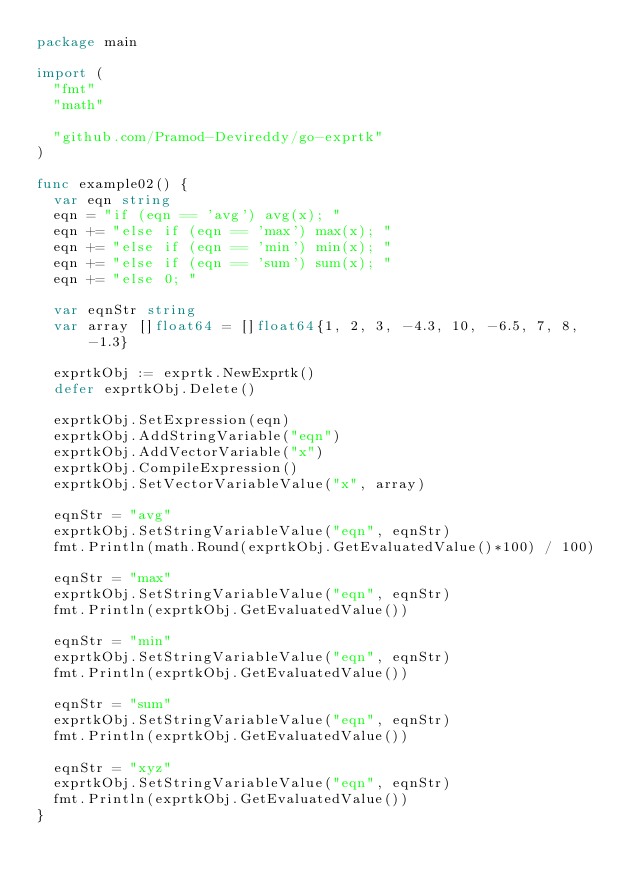<code> <loc_0><loc_0><loc_500><loc_500><_Go_>package main

import (
	"fmt"
	"math"

	"github.com/Pramod-Devireddy/go-exprtk"
)

func example02() {
	var eqn string
	eqn = "if (eqn == 'avg') avg(x); "
	eqn += "else if (eqn == 'max') max(x); "
	eqn += "else if (eqn == 'min') min(x); "
	eqn += "else if (eqn == 'sum') sum(x); "
	eqn += "else 0; "

	var eqnStr string
	var array []float64 = []float64{1, 2, 3, -4.3, 10, -6.5, 7, 8, -1.3}

	exprtkObj := exprtk.NewExprtk()
	defer exprtkObj.Delete()

	exprtkObj.SetExpression(eqn)
	exprtkObj.AddStringVariable("eqn")
	exprtkObj.AddVectorVariable("x")
	exprtkObj.CompileExpression()
	exprtkObj.SetVectorVariableValue("x", array)

	eqnStr = "avg"
	exprtkObj.SetStringVariableValue("eqn", eqnStr)
	fmt.Println(math.Round(exprtkObj.GetEvaluatedValue()*100) / 100)

	eqnStr = "max"
	exprtkObj.SetStringVariableValue("eqn", eqnStr)
	fmt.Println(exprtkObj.GetEvaluatedValue())

	eqnStr = "min"
	exprtkObj.SetStringVariableValue("eqn", eqnStr)
	fmt.Println(exprtkObj.GetEvaluatedValue())

	eqnStr = "sum"
	exprtkObj.SetStringVariableValue("eqn", eqnStr)
	fmt.Println(exprtkObj.GetEvaluatedValue())

	eqnStr = "xyz"
	exprtkObj.SetStringVariableValue("eqn", eqnStr)
	fmt.Println(exprtkObj.GetEvaluatedValue())
}
</code> 